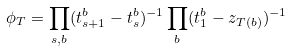<formula> <loc_0><loc_0><loc_500><loc_500>\phi _ { T } = \prod _ { s , b } ( t ^ { b } _ { s + 1 } - t ^ { b } _ { s } ) ^ { - 1 } \prod _ { b } ( t ^ { b } _ { 1 } - z _ { T ( b ) } ) ^ { - 1 }</formula> 